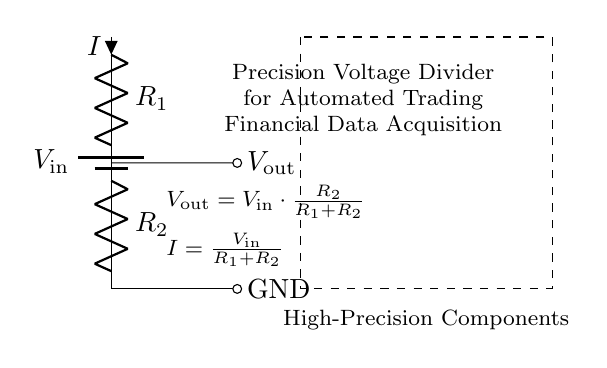What is the input voltage depicted in the circuit? The input voltage is labeled as V in the circuit diagram, representing the voltage supplied to the voltage divider.
Answer: V in What are the resistance values used in the voltage divider? The circuit includes two resistors labeled R1 and R2, but specific values are not provided in the diagram.
Answer: R1 and R2 What is the output voltage formula for this voltage divider? The output voltage is determined by the formula V out = V in multiplied by R2 divided by the sum of R1 and R2, as indicated on the diagram.
Answer: V out = V in × R2 / (R1 + R2) What is the current through the resistors in this configuration? The current I is calculated using I = V in divided by the sum of R1 and R2, according to the formula presented in the diagram.
Answer: I = V in / (R1 + R2) What is the purpose of using high-precision components in this circuit? High-precision components ensure accurate voltage readings and help maintain the stability necessary for financial data acquisition in automated trading systems.
Answer: Accuracy in measurements How will changing R1 affect the output voltage? Increasing R1 will decrease the output voltage V out due to the voltage divider effect, where the output is dependent on the ratio of the resistances.
Answer: Decrease V out Which element connects the output voltage to the external circuit? A short line to the right connects the output voltage labeled V out, indicating where the voltage is taken from the divider for further use.
Answer: Short line 